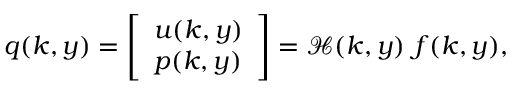<formula> <loc_0><loc_0><loc_500><loc_500>q ( k , y ) = \left [ \begin{array} { l } { u ( k , y ) } \\ { p ( k , y ) } \end{array} \right ] = \mathcal { H } ( k , y ) f ( k , y ) ,</formula> 